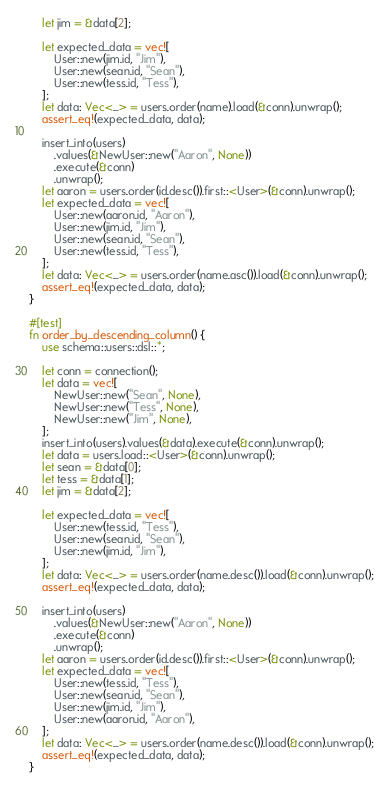Convert code to text. <code><loc_0><loc_0><loc_500><loc_500><_Rust_>    let jim = &data[2];

    let expected_data = vec![
        User::new(jim.id, "Jim"),
        User::new(sean.id, "Sean"),
        User::new(tess.id, "Tess"),
    ];
    let data: Vec<_> = users.order(name).load(&conn).unwrap();
    assert_eq!(expected_data, data);

    insert_into(users)
        .values(&NewUser::new("Aaron", None))
        .execute(&conn)
        .unwrap();
    let aaron = users.order(id.desc()).first::<User>(&conn).unwrap();
    let expected_data = vec![
        User::new(aaron.id, "Aaron"),
        User::new(jim.id, "Jim"),
        User::new(sean.id, "Sean"),
        User::new(tess.id, "Tess"),
    ];
    let data: Vec<_> = users.order(name.asc()).load(&conn).unwrap();
    assert_eq!(expected_data, data);
}

#[test]
fn order_by_descending_column() {
    use schema::users::dsl::*;

    let conn = connection();
    let data = vec![
        NewUser::new("Sean", None),
        NewUser::new("Tess", None),
        NewUser::new("Jim", None),
    ];
    insert_into(users).values(&data).execute(&conn).unwrap();
    let data = users.load::<User>(&conn).unwrap();
    let sean = &data[0];
    let tess = &data[1];
    let jim = &data[2];

    let expected_data = vec![
        User::new(tess.id, "Tess"),
        User::new(sean.id, "Sean"),
        User::new(jim.id, "Jim"),
    ];
    let data: Vec<_> = users.order(name.desc()).load(&conn).unwrap();
    assert_eq!(expected_data, data);

    insert_into(users)
        .values(&NewUser::new("Aaron", None))
        .execute(&conn)
        .unwrap();
    let aaron = users.order(id.desc()).first::<User>(&conn).unwrap();
    let expected_data = vec![
        User::new(tess.id, "Tess"),
        User::new(sean.id, "Sean"),
        User::new(jim.id, "Jim"),
        User::new(aaron.id, "Aaron"),
    ];
    let data: Vec<_> = users.order(name.desc()).load(&conn).unwrap();
    assert_eq!(expected_data, data);
}
</code> 